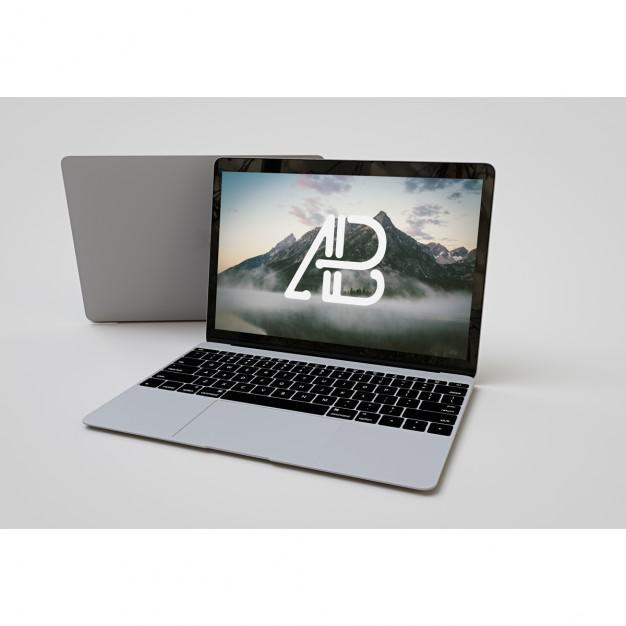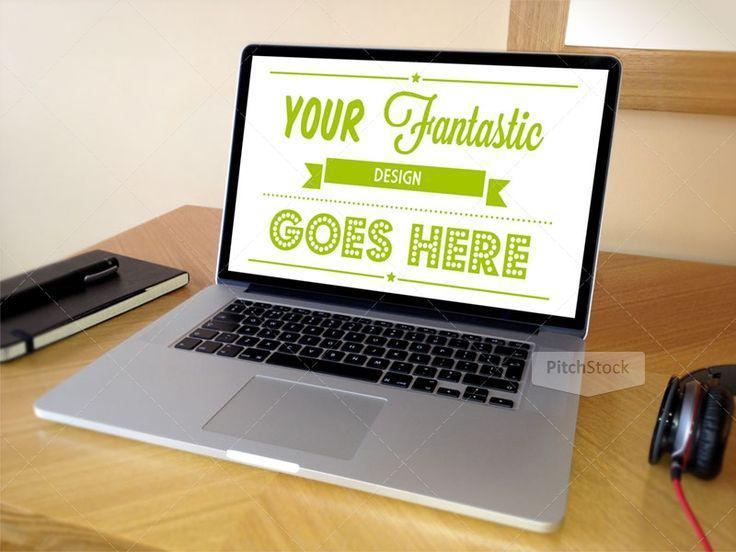The first image is the image on the left, the second image is the image on the right. Assess this claim about the two images: "The left image shows exactly one open forward-facing laptop on a white table, and the right image shows one open, forward-facing laptop overlapping another open, forward-facing laptop.". Correct or not? Answer yes or no. No. 